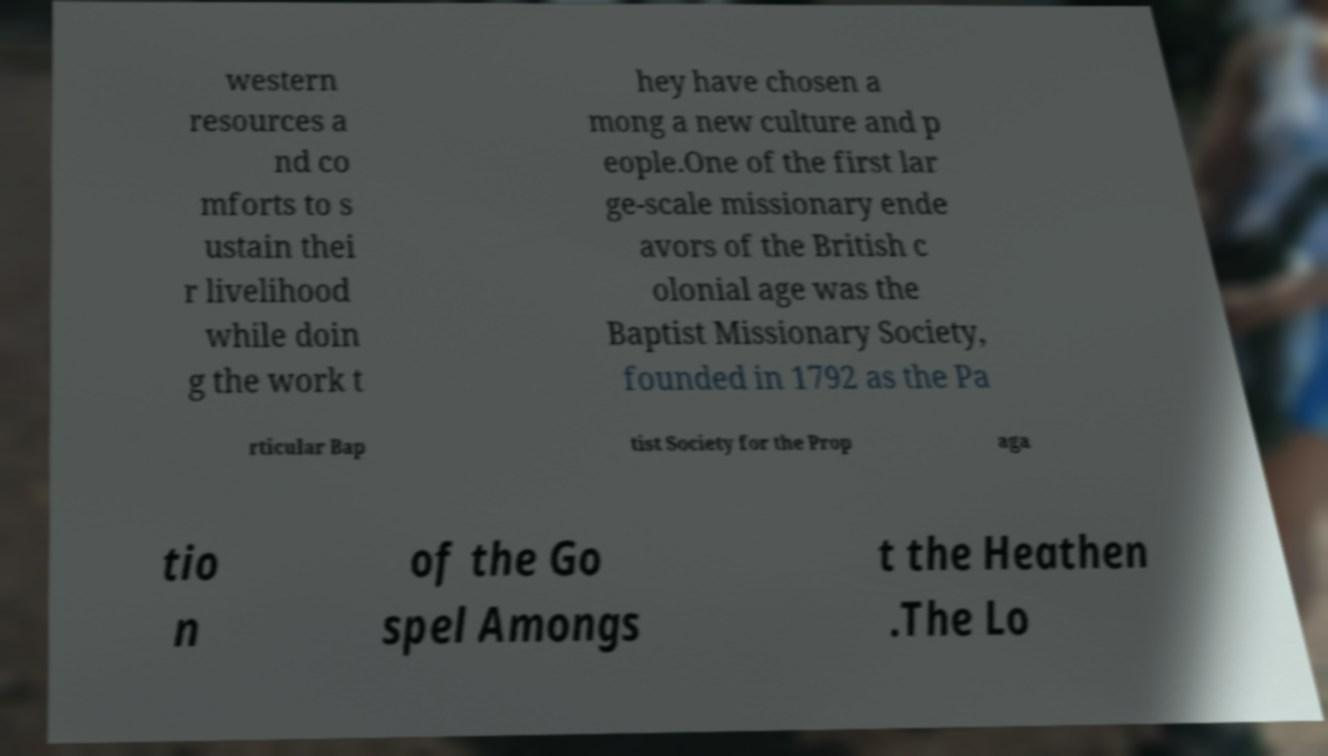For documentation purposes, I need the text within this image transcribed. Could you provide that? western resources a nd co mforts to s ustain thei r livelihood while doin g the work t hey have chosen a mong a new culture and p eople.One of the first lar ge-scale missionary ende avors of the British c olonial age was the Baptist Missionary Society, founded in 1792 as the Pa rticular Bap tist Society for the Prop aga tio n of the Go spel Amongs t the Heathen .The Lo 